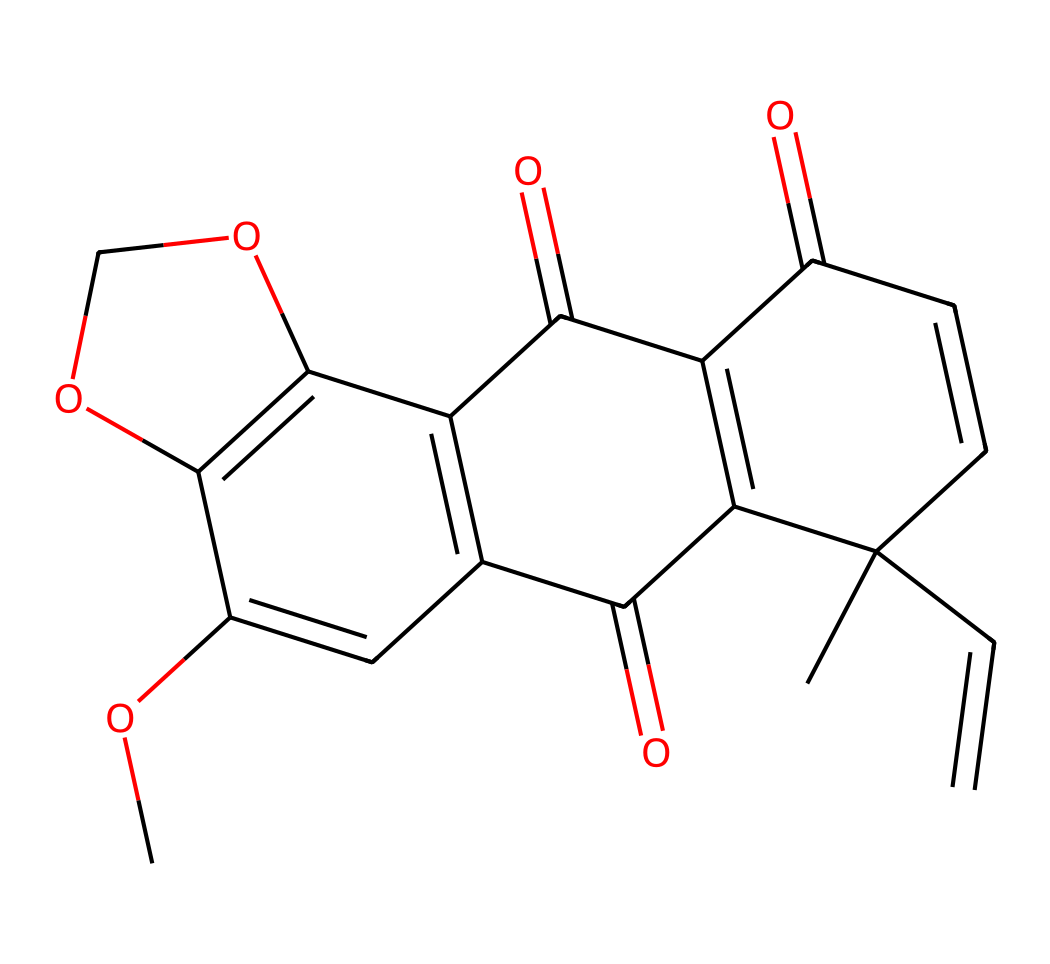What is the molecular formula of rotenone? To find the molecular formula from the SMILES notation, we identify the number of each type of atom present. The structure represents 21 carbon atoms (C), 22 hydrogen atoms (H), and 6 oxygen atoms (O). Therefore, the molecular formula can be derived as C21H22O6.
Answer: C21H22O6 How many rings are present in the chemical structure? By analyzing the chemical structure, we can identify that there are four distinct rings formed by the cyclic components indicated in the SMILES notation. Each of these rings contributes to the overall shape of the molecule.
Answer: 4 What type of chemical is rotenone classified as? Given the presence of imide functional groups, which are characterized by carbonyl groups adjacent to nitrogen, along with the presence of multiple carbon rings and double bonds, this compound is classified as a natural product with insecticidal properties, specifically an imide.
Answer: imide What is the role of carbonyl groups in rotenone? Carbonyl groups are pivotal in the structure of rotenone as they contribute to the compound's reactivity and potential as an insecticide. The presence of multiple carbonyl groups indicates sites for chemical reactions, enhancing its effectiveness.
Answer: reactivity How many oxygen atoms are in the structure of rotenone? From the analysis of the SMILES notation, we can count the distinct oxygen atoms indicated. There are 6 oxygen atoms incorporated within the entire structure, which can be determined by examining each part of the notation.
Answer: 6 What type of bonds are present in rotenone? In the SMILES structure, we see a combination of single and double bonds forming the resilience and structure of the molecule. Specifically, there are both carbon-carbon single bonds and carbon-carbon double bonds, as well as carbon-oxygen double bonds identified as carbonyl groups.
Answer: single and double bonds 